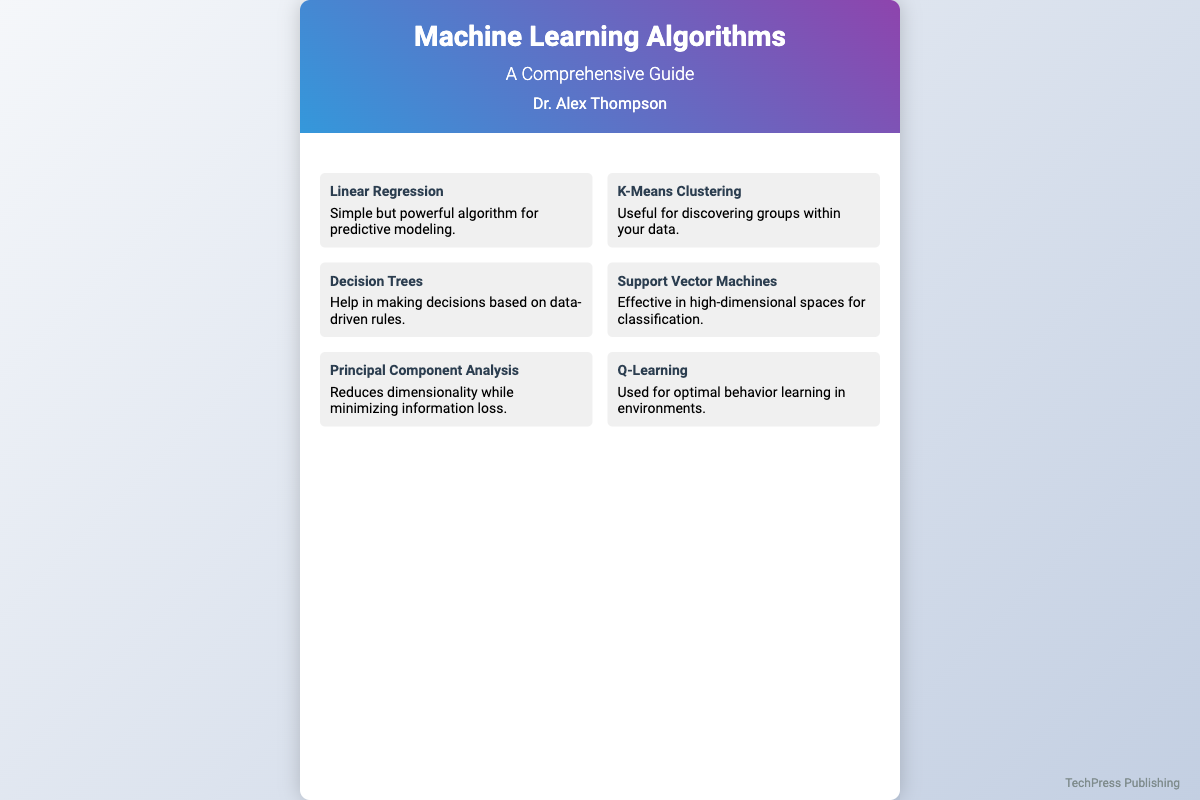What is the title of the book? The title of the book is prominently displayed in the header section.
Answer: Machine Learning Algorithms Who is the author of the book? The author's name is mentioned below the title and subtitle in the header section.
Answer: Dr. Alex Thompson What type of cover is this document showcasing? This document showcases a book cover design, which includes a title, author, and algorithm descriptions.
Answer: Book cover How many algorithms are displayed on the cover? There are six algorithm cards featured within the content area of the cover.
Answer: Six What algorithm is described as "Useful for discovering groups within your data"? This description refers to one specific algorithm listed in the algorithm grid.
Answer: K-Means Clustering Which algorithm is associated with "Reduces dimensionality while minimizing information loss"? This phrase describes an algorithm that aids in data processing and visualization found in the document.
Answer: Principal Component Analysis What visual feature allows the algorithms to be distinguished? The card layout utilizes a grid structure with distinct borders for each algorithm.
Answer: Grid structure Which algorithm focuses on "optimal behavior learning in environments"? This algorithm is specifically designed for reinforcement learning scenarios mentioned in the document.
Answer: Q-Learning 